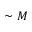Convert formula to latex. <formula><loc_0><loc_0><loc_500><loc_500>\sim M</formula> 